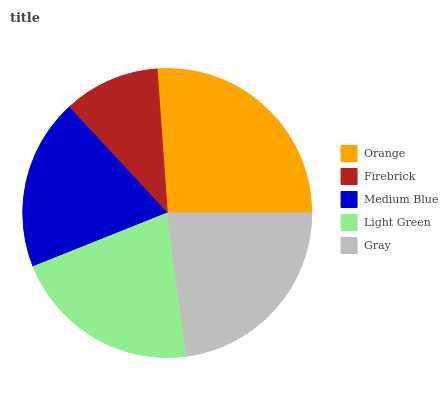Is Firebrick the minimum?
Answer yes or no. Yes. Is Orange the maximum?
Answer yes or no. Yes. Is Medium Blue the minimum?
Answer yes or no. No. Is Medium Blue the maximum?
Answer yes or no. No. Is Medium Blue greater than Firebrick?
Answer yes or no. Yes. Is Firebrick less than Medium Blue?
Answer yes or no. Yes. Is Firebrick greater than Medium Blue?
Answer yes or no. No. Is Medium Blue less than Firebrick?
Answer yes or no. No. Is Light Green the high median?
Answer yes or no. Yes. Is Light Green the low median?
Answer yes or no. Yes. Is Gray the high median?
Answer yes or no. No. Is Medium Blue the low median?
Answer yes or no. No. 